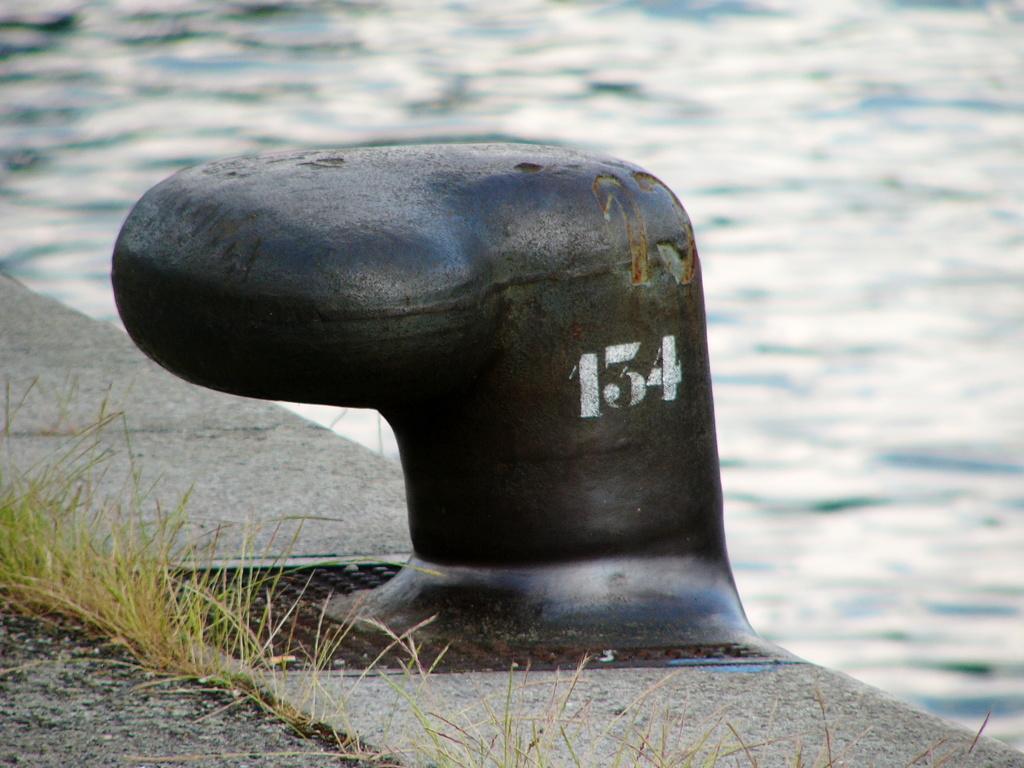Could you give a brief overview of what you see in this image? Something written on this black object. Background it is blurry and we can see water. This is grass. 